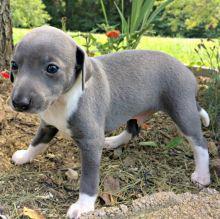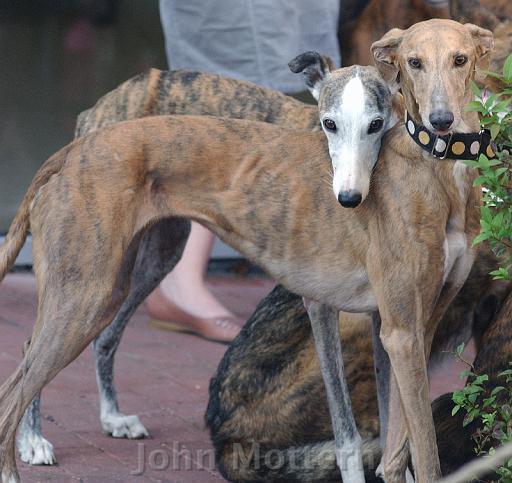The first image is the image on the left, the second image is the image on the right. Considering the images on both sides, is "In one image, are two dogs facing towards the camera." valid? Answer yes or no. Yes. The first image is the image on the left, the second image is the image on the right. For the images shown, is this caption "All of the dogs are outside and none of them is wearing a collar." true? Answer yes or no. No. 